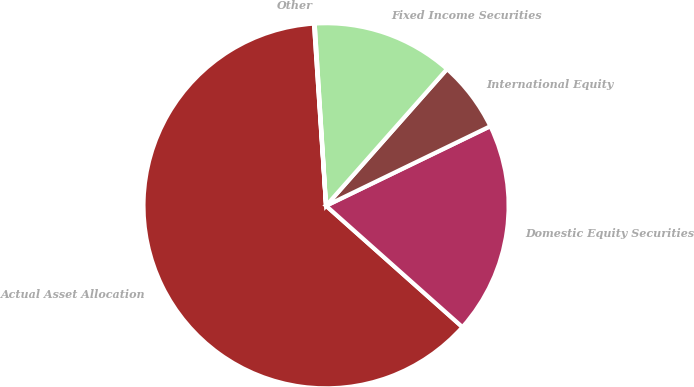Convert chart to OTSL. <chart><loc_0><loc_0><loc_500><loc_500><pie_chart><fcel>Actual Asset Allocation<fcel>Domestic Equity Securities<fcel>International Equity<fcel>Fixed Income Securities<fcel>Other<nl><fcel>62.37%<fcel>18.75%<fcel>6.29%<fcel>12.52%<fcel>0.06%<nl></chart> 